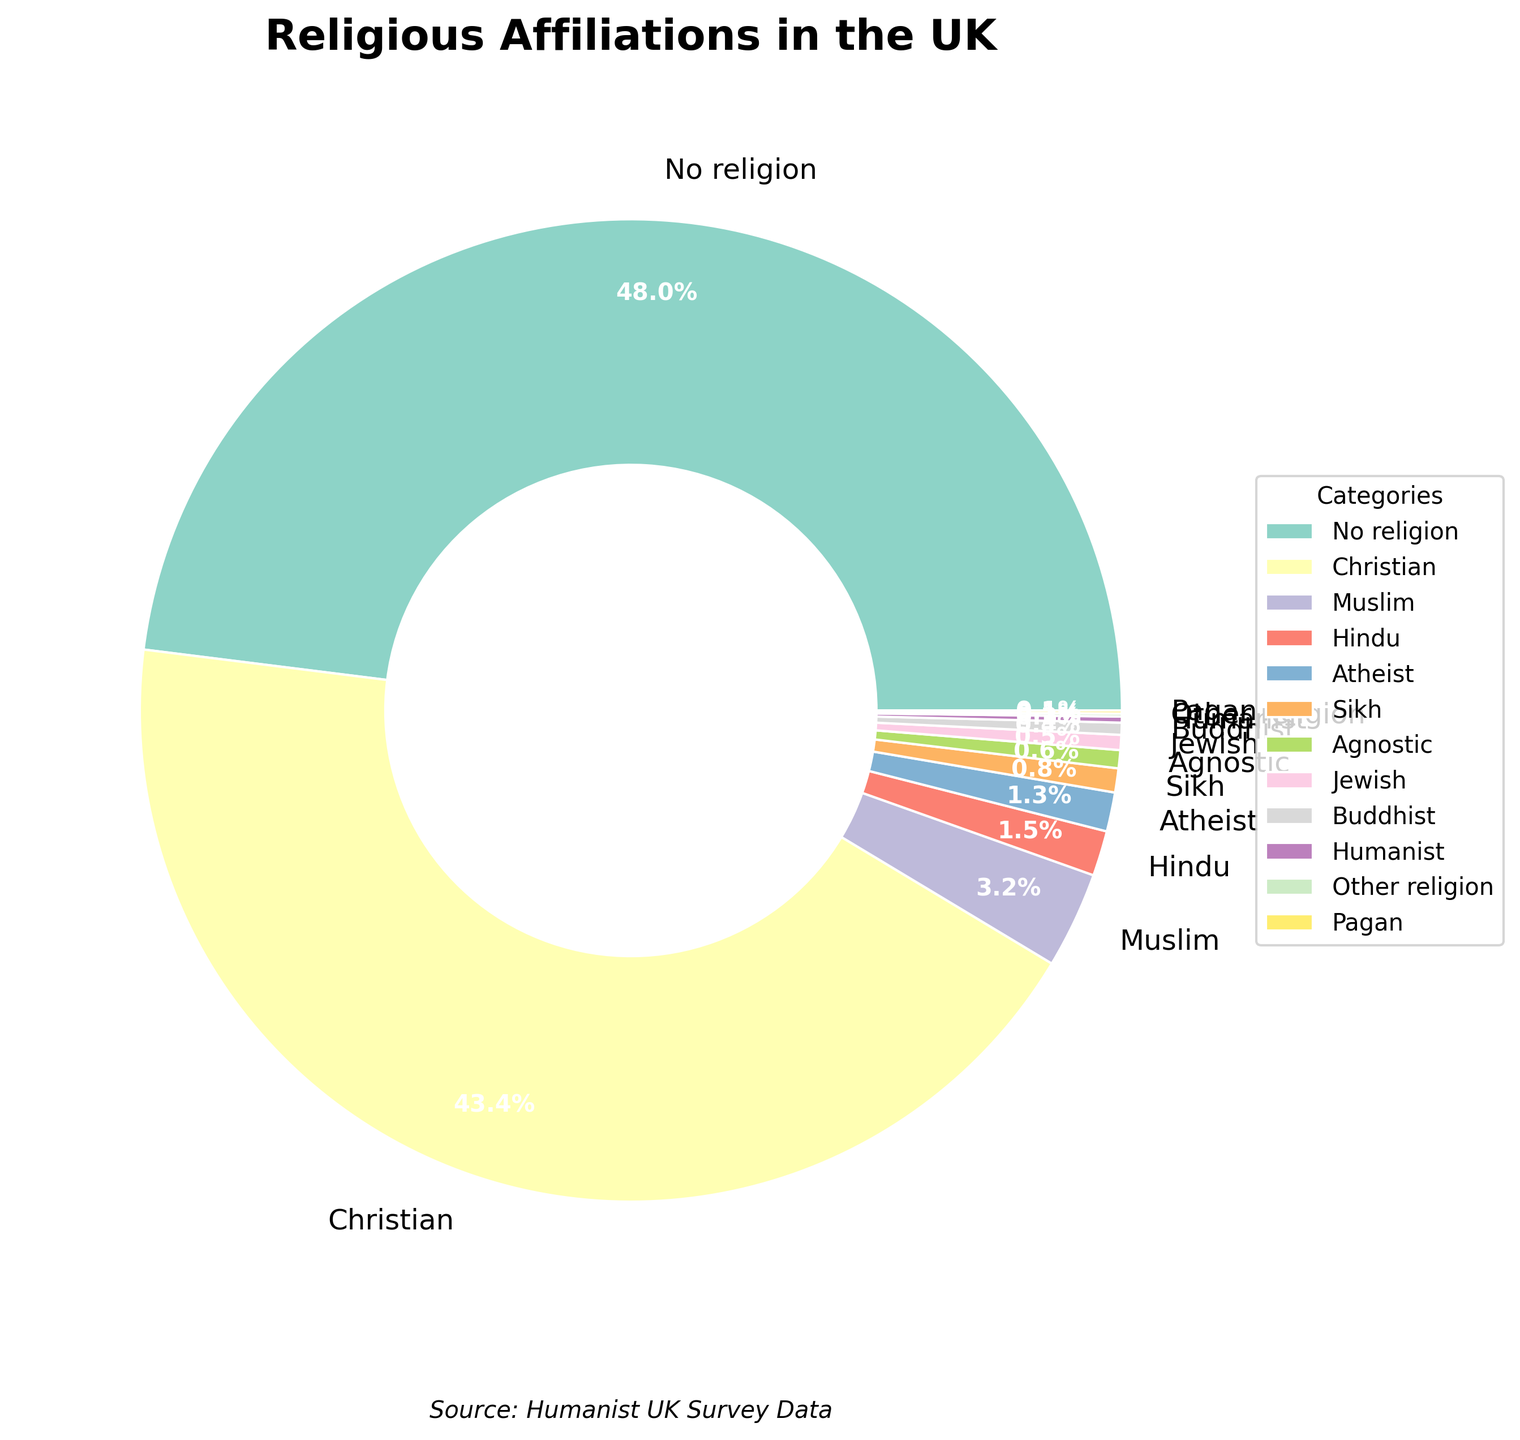What is the percentage of people who identify as non-religious (including 'No religion' and 'Atheist')? To find the total percentage of people who identify as non-religious, you need to add the percentages of 'No religion' and 'Atheist'. According to the figure, 'No religion' is 48.5% and 'Atheist' is 1.3%. Thus, 48.5 + 1.3 = 49.8%.
Answer: 49.8% Which religious affiliation has the highest percentage, and what is it? To determine the highest percentage, look for the largest segment in the pie chart. 'No religion' has the highest percentage at 48.5%.
Answer: No religion, 48.5% How much larger is the Christian group compared to the Muslim group? To find the difference in percentages between the Christian and Muslim groups, subtract the Muslim percentage from the Christian percentage. According to the figure, Christians are 43.8% and Muslims are 3.2%, so 43.8 - 3.2 = 40.6%.
Answer: 40.6% What fraction of the total population is represented by 'Agnostic' and 'Humanist' combined? To find the combined percentage, add the percentages of 'Agnostic' and 'Humanist'. 'Agnostic' is 0.6% and 'Humanist' is 0.2%, giving a combined percentage of 0.6 + 0.2 = 0.8%.
Answer: 0.8% Which categories have a percentage of 1.0% or more? To find the categories greater than or equal to 1.0%, look at the pie chart percentages. The relevant categories are 'No religion' (48.5%), 'Christian' (43.8%), 'Muslim' (3.2%), 'Hindu' (1.5%), and 'Atheist' (1.3%).
Answer: No religion, Christian, Muslim, Hindu, Atheist Is the percentage of Sikhs greater or less than that of Jews? Comparing the percentages, Sikhs are 0.8% and Jews are 0.5%. Sikhs have a greater percentage than Jews.
Answer: Greater What is the percentage difference between Buddhists and Hindus? Subtract the smaller percentage from the larger percentage. Hindus are 1.5% and Buddhists are 0.4%, so the difference is 1.5 - 0.4 = 1.1%.
Answer: 1.1% Which religious affiliation represents the smallest proportion of the population? The smallest segment on the pie chart represents 'Pagan' and 'Other religion', each at 0.1%.
Answer: Pagan, Other religion (tied) What proportion of the population identifies with religions other than 'No religion' and 'Christian'? Sum the percentages of all categories except 'No religion' and 'Christian'. Other groups represent the total population minus the percentage of 'No religion' and 'Christian'. So, 100 - (48.5 + 43.8) = 7.7%.
Answer: 7.7% Are there more people identifying as 'Muslim' or 'Atheist'? By comparing the percentages, Muslims are 3.2% and Atheists are 1.3%. There are more people identifying as Muslim.
Answer: Muslim 